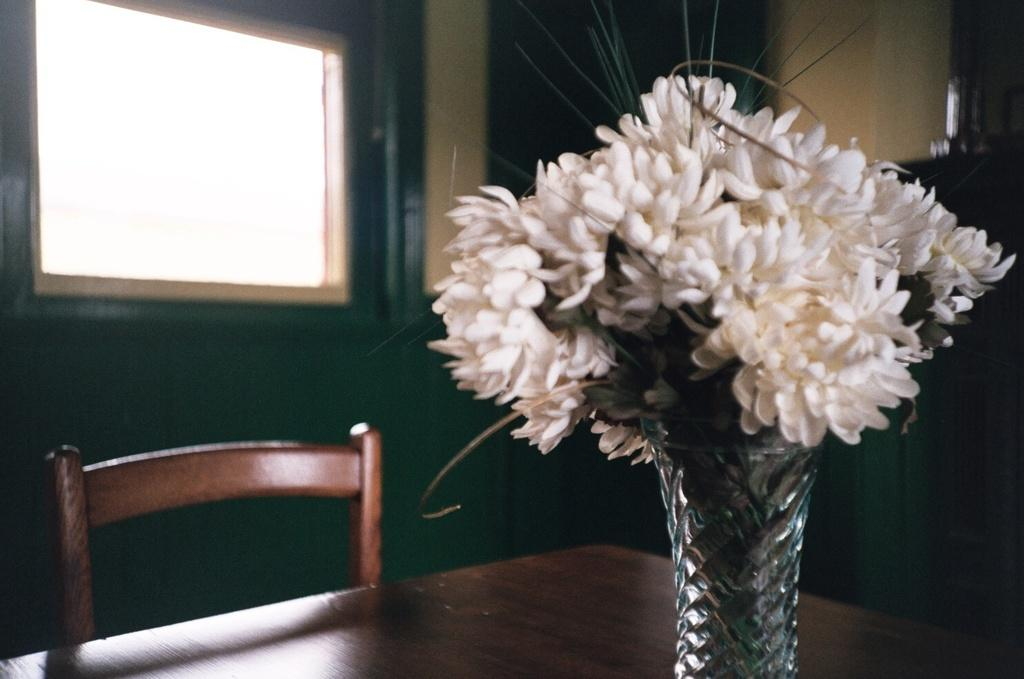What is located in the middle of the image? There is a table in the middle of the image. What is placed on the table? There is a flower vase on the table. What is in front of the table? There is a chair in front of the table. What can be seen in the background of the image? There is a window and a wall in the background of the image. What type of flame can be seen coming from the cat in the image? There is no cat present in the image, and therefore no flame can be seen coming from it. 